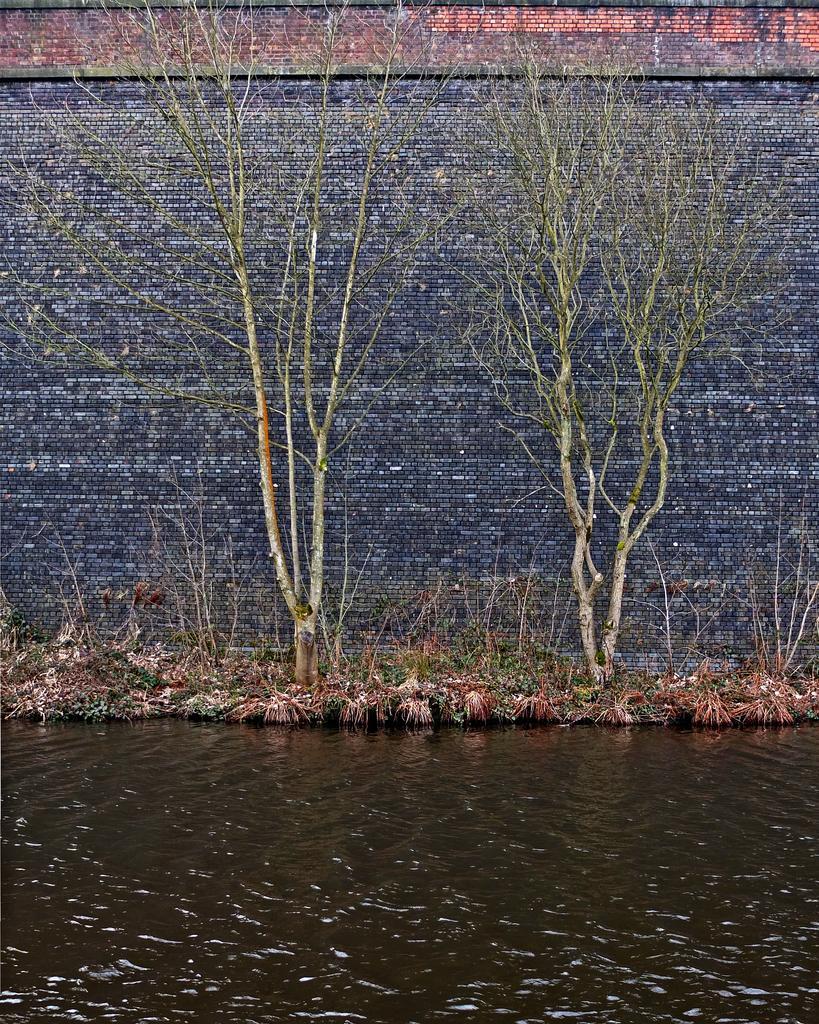How would you summarize this image in a sentence or two? In this image I can see the water. To the side of the water I can see the grass and the trees. In the background I can see the wall which is in grey and brown color. 